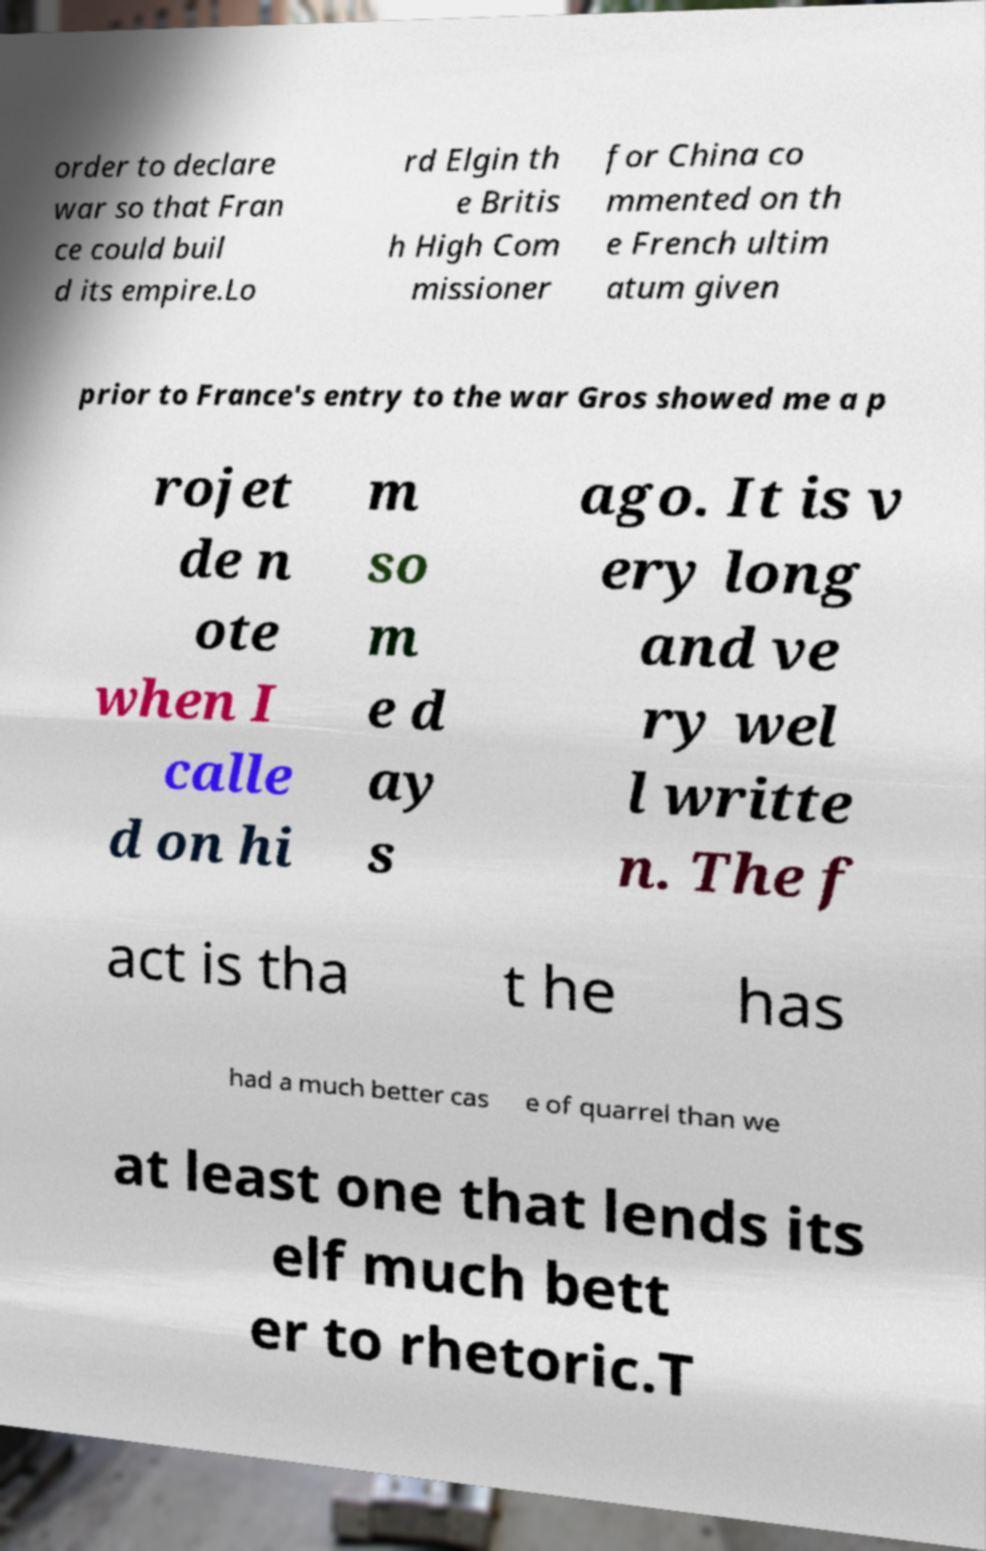I need the written content from this picture converted into text. Can you do that? order to declare war so that Fran ce could buil d its empire.Lo rd Elgin th e Britis h High Com missioner for China co mmented on th e French ultim atum given prior to France's entry to the war Gros showed me a p rojet de n ote when I calle d on hi m so m e d ay s ago. It is v ery long and ve ry wel l writte n. The f act is tha t he has had a much better cas e of quarrel than we at least one that lends its elf much bett er to rhetoric.T 